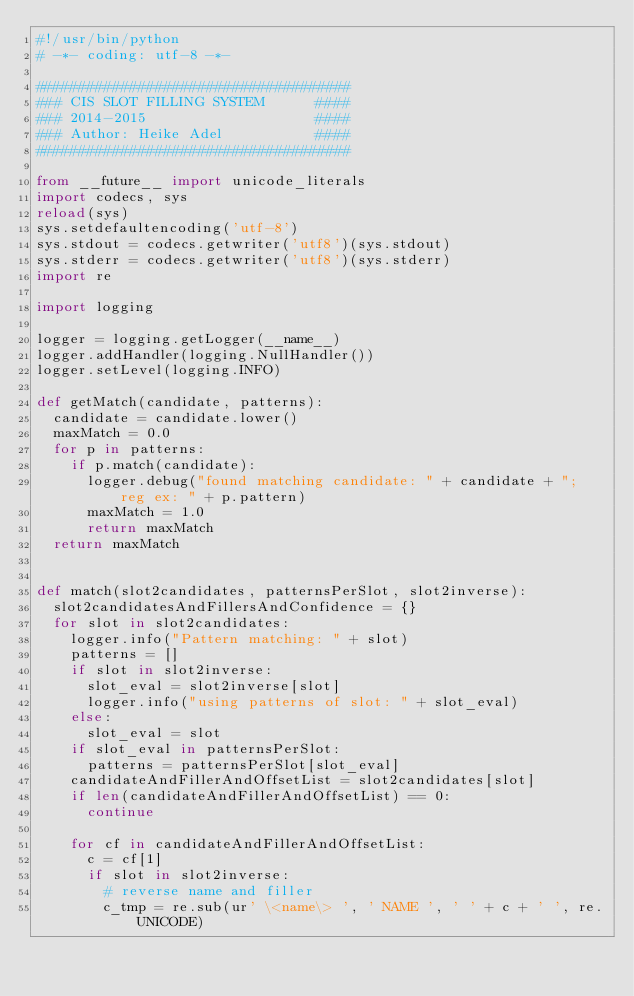Convert code to text. <code><loc_0><loc_0><loc_500><loc_500><_Python_>#!/usr/bin/python
# -*- coding: utf-8 -*-

#####################################
### CIS SLOT FILLING SYSTEM      ####
### 2014-2015                    ####
### Author: Heike Adel           ####
#####################################

from __future__ import unicode_literals
import codecs, sys
reload(sys)
sys.setdefaultencoding('utf-8')
sys.stdout = codecs.getwriter('utf8')(sys.stdout)
sys.stderr = codecs.getwriter('utf8')(sys.stderr)
import re

import logging

logger = logging.getLogger(__name__)
logger.addHandler(logging.NullHandler())
logger.setLevel(logging.INFO)

def getMatch(candidate, patterns):
  candidate = candidate.lower()
  maxMatch = 0.0
  for p in patterns:
    if p.match(candidate):
      logger.debug("found matching candidate: " + candidate + "; reg ex: " + p.pattern)
      maxMatch = 1.0
      return maxMatch
  return maxMatch


def match(slot2candidates, patternsPerSlot, slot2inverse):
  slot2candidatesAndFillersAndConfidence = {}
  for slot in slot2candidates:
    logger.info("Pattern matching: " + slot)
    patterns = []
    if slot in slot2inverse:
      slot_eval = slot2inverse[slot]
      logger.info("using patterns of slot: " + slot_eval)
    else:
      slot_eval = slot
    if slot_eval in patternsPerSlot:
      patterns = patternsPerSlot[slot_eval]
    candidateAndFillerAndOffsetList = slot2candidates[slot]
    if len(candidateAndFillerAndOffsetList) == 0:
      continue

    for cf in candidateAndFillerAndOffsetList:
      c = cf[1]
      if slot in slot2inverse:
        # reverse name and filler
        c_tmp = re.sub(ur' \<name\> ', ' NAME ', ' ' + c + ' ', re.UNICODE)</code> 